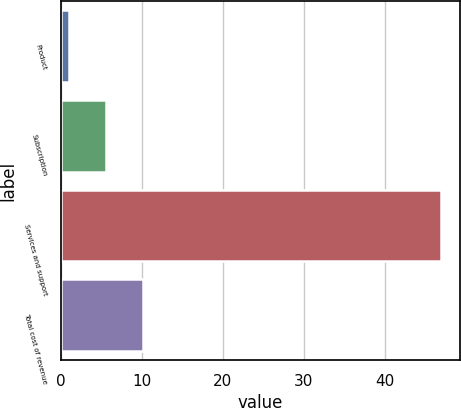Convert chart. <chart><loc_0><loc_0><loc_500><loc_500><bar_chart><fcel>Product<fcel>Subscription<fcel>Services and support<fcel>Total cost of revenue<nl><fcel>1<fcel>5.6<fcel>47<fcel>10.2<nl></chart> 